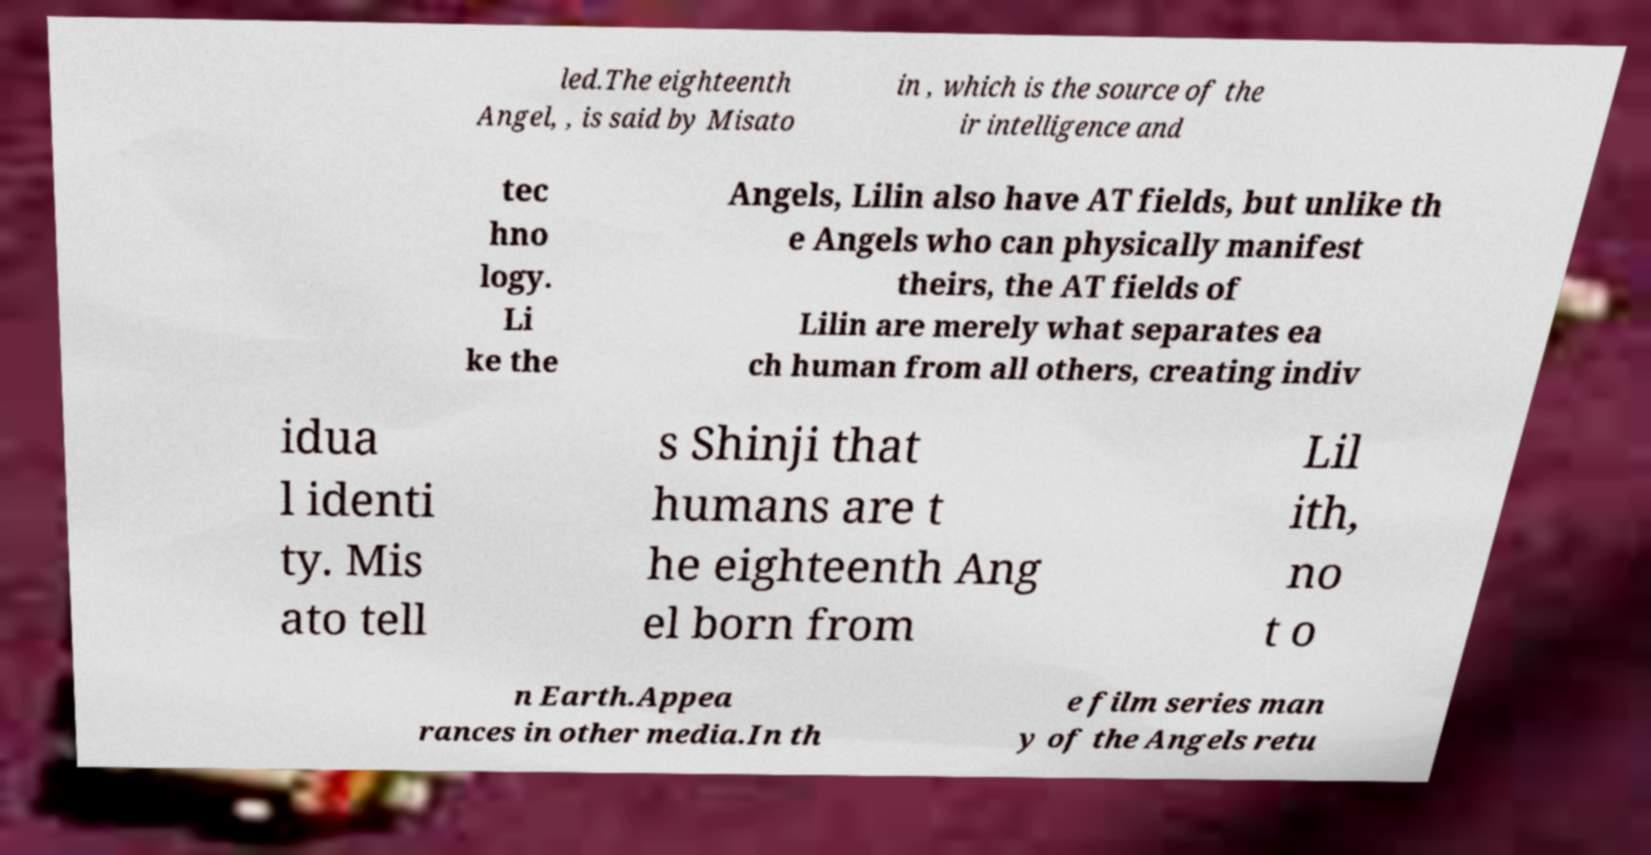For documentation purposes, I need the text within this image transcribed. Could you provide that? led.The eighteenth Angel, , is said by Misato in , which is the source of the ir intelligence and tec hno logy. Li ke the Angels, Lilin also have AT fields, but unlike th e Angels who can physically manifest theirs, the AT fields of Lilin are merely what separates ea ch human from all others, creating indiv idua l identi ty. Mis ato tell s Shinji that humans are t he eighteenth Ang el born from Lil ith, no t o n Earth.Appea rances in other media.In th e film series man y of the Angels retu 